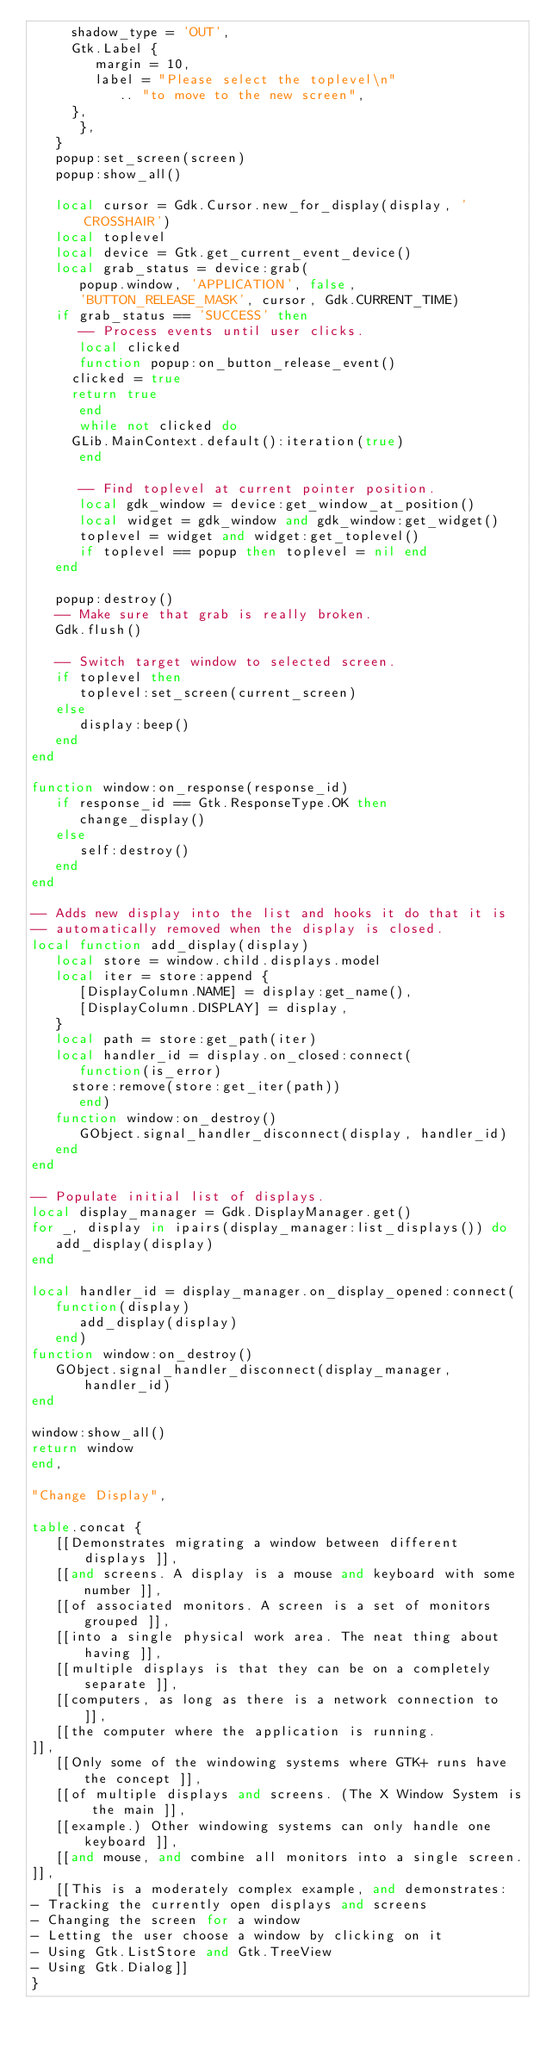Convert code to text. <code><loc_0><loc_0><loc_500><loc_500><_Lua_>	 shadow_type = 'OUT',
	 Gtk.Label {
	    margin = 10,
	    label = "Please select the toplevel\n"
	       .. "to move to the new screen",
	 },
      },
   }
   popup:set_screen(screen)
   popup:show_all()

   local cursor = Gdk.Cursor.new_for_display(display, 'CROSSHAIR')
   local toplevel
   local device = Gtk.get_current_event_device()
   local grab_status = device:grab(
      popup.window, 'APPLICATION', false,
      'BUTTON_RELEASE_MASK', cursor, Gdk.CURRENT_TIME)
   if grab_status == 'SUCCESS' then
      -- Process events until user clicks.
      local clicked
      function popup:on_button_release_event()
	 clicked = true
	 return true
      end
      while not clicked do
	 GLib.MainContext.default():iteration(true)
      end

      -- Find toplevel at current pointer position.
      local gdk_window = device:get_window_at_position()
      local widget = gdk_window and gdk_window:get_widget()
      toplevel = widget and widget:get_toplevel()
      if toplevel == popup then toplevel = nil end
   end

   popup:destroy()
   -- Make sure that grab is really broken.
   Gdk.flush()

   -- Switch target window to selected screen.
   if toplevel then
      toplevel:set_screen(current_screen)
   else
      display:beep()
   end
end

function window:on_response(response_id)
   if response_id == Gtk.ResponseType.OK then
      change_display()
   else
      self:destroy()
   end
end

-- Adds new display into the list and hooks it do that it is
-- automatically removed when the display is closed.
local function add_display(display)
   local store = window.child.displays.model
   local iter = store:append {
      [DisplayColumn.NAME] = display:get_name(),
      [DisplayColumn.DISPLAY] = display,
   }
   local path = store:get_path(iter)
   local handler_id = display.on_closed:connect(
      function(is_error)
	 store:remove(store:get_iter(path))
      end)
   function window:on_destroy()
      GObject.signal_handler_disconnect(display, handler_id)
   end
end

-- Populate initial list of displays.
local display_manager = Gdk.DisplayManager.get()
for _, display in ipairs(display_manager:list_displays()) do
   add_display(display)
end

local handler_id = display_manager.on_display_opened:connect(
   function(display)
      add_display(display)
   end)
function window:on_destroy()
   GObject.signal_handler_disconnect(display_manager, handler_id)
end

window:show_all()
return window
end,

"Change Display",

table.concat {
   [[Demonstrates migrating a window between different displays ]],
   [[and screens. A display is a mouse and keyboard with some number ]],
   [[of associated monitors. A screen is a set of monitors grouped ]],
   [[into a single physical work area. The neat thing about having ]],
   [[multiple displays is that they can be on a completely separate ]],
   [[computers, as long as there is a network connection to ]],
   [[the computer where the application is running.
]],
   [[Only some of the windowing systems where GTK+ runs have the concept ]],
   [[of multiple displays and screens. (The X Window System is the main ]],
   [[example.) Other windowing systems can only handle one keyboard ]],
   [[and mouse, and combine all monitors into a single screen.
]],
   [[This is a moderately complex example, and demonstrates:
- Tracking the currently open displays and screens
- Changing the screen for a window
- Letting the user choose a window by clicking on it
- Using Gtk.ListStore and Gtk.TreeView
- Using Gtk.Dialog]]
}
</code> 